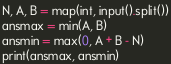Convert code to text. <code><loc_0><loc_0><loc_500><loc_500><_Python_>N, A, B = map(int, input().split())
ansmax = min(A, B)
ansmin = max(0, A + B - N)
print(ansmax, ansmin)</code> 